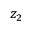Convert formula to latex. <formula><loc_0><loc_0><loc_500><loc_500>z _ { 2 }</formula> 